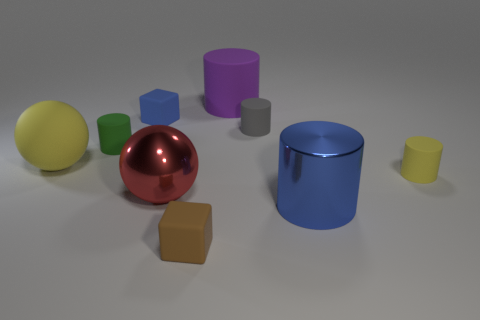Can you infer anything about the texture of the surfaces in the picture? The surfaces in the image appear to have a mix of textures. The big red sphere has a shiny, reflective surface, suggesting it is smooth and glossy. In contrast, the large blue cylinder seems to have a less reflective matte finish, indicating a textured or less smooth surface. 